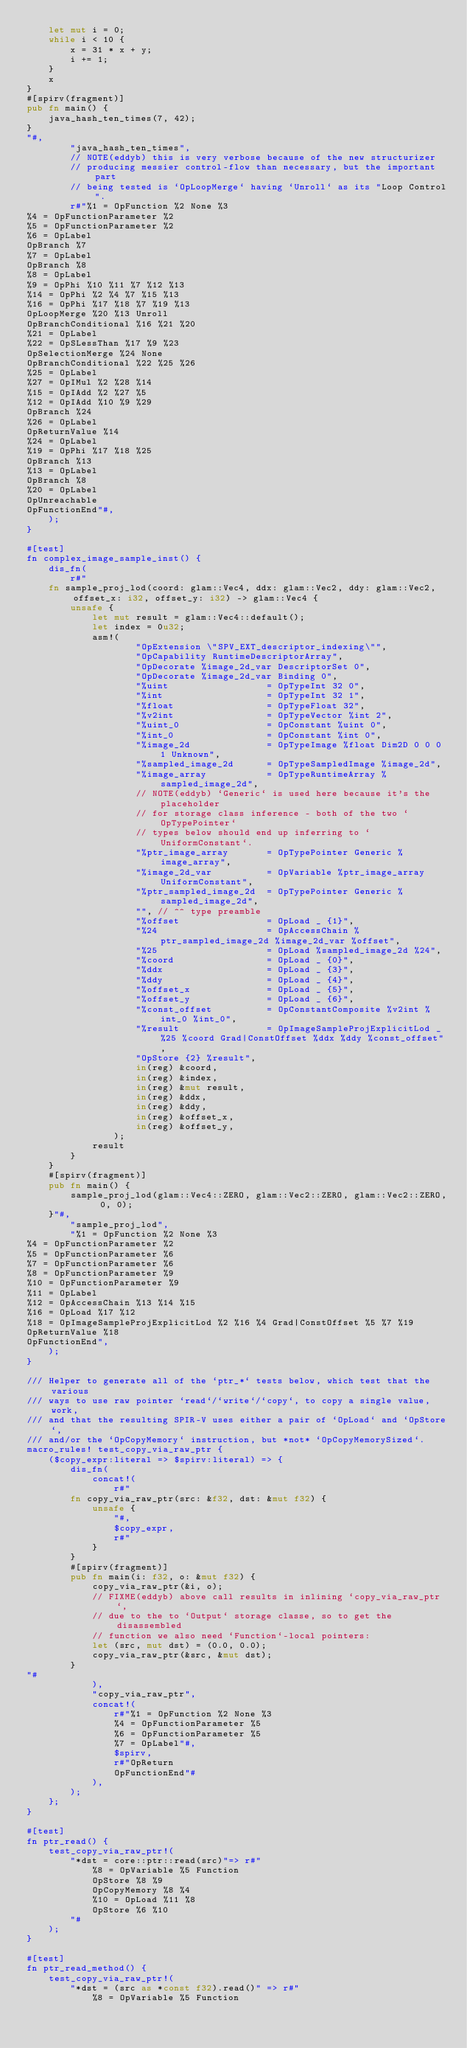Convert code to text. <code><loc_0><loc_0><loc_500><loc_500><_Rust_>    let mut i = 0;
    while i < 10 {
        x = 31 * x + y;
        i += 1;
    }
    x
}
#[spirv(fragment)]
pub fn main() {
    java_hash_ten_times(7, 42);
}
"#,
        "java_hash_ten_times",
        // NOTE(eddyb) this is very verbose because of the new structurizer
        // producing messier control-flow than necessary, but the important part
        // being tested is `OpLoopMerge` having `Unroll` as its "Loop Control".
        r#"%1 = OpFunction %2 None %3
%4 = OpFunctionParameter %2
%5 = OpFunctionParameter %2
%6 = OpLabel
OpBranch %7
%7 = OpLabel
OpBranch %8
%8 = OpLabel
%9 = OpPhi %10 %11 %7 %12 %13
%14 = OpPhi %2 %4 %7 %15 %13
%16 = OpPhi %17 %18 %7 %19 %13
OpLoopMerge %20 %13 Unroll
OpBranchConditional %16 %21 %20
%21 = OpLabel
%22 = OpSLessThan %17 %9 %23
OpSelectionMerge %24 None
OpBranchConditional %22 %25 %26
%25 = OpLabel
%27 = OpIMul %2 %28 %14
%15 = OpIAdd %2 %27 %5
%12 = OpIAdd %10 %9 %29
OpBranch %24
%26 = OpLabel
OpReturnValue %14
%24 = OpLabel
%19 = OpPhi %17 %18 %25
OpBranch %13
%13 = OpLabel
OpBranch %8
%20 = OpLabel
OpUnreachable
OpFunctionEnd"#,
    );
}

#[test]
fn complex_image_sample_inst() {
    dis_fn(
        r#"
    fn sample_proj_lod(coord: glam::Vec4, ddx: glam::Vec2, ddy: glam::Vec2, offset_x: i32, offset_y: i32) -> glam::Vec4 {
        unsafe {
            let mut result = glam::Vec4::default();
            let index = 0u32;
            asm!(
                    "OpExtension \"SPV_EXT_descriptor_indexing\"",
                    "OpCapability RuntimeDescriptorArray",
                    "OpDecorate %image_2d_var DescriptorSet 0",
                    "OpDecorate %image_2d_var Binding 0",
                    "%uint                  = OpTypeInt 32 0",
                    "%int                   = OpTypeInt 32 1",
                    "%float                 = OpTypeFloat 32",
                    "%v2int                 = OpTypeVector %int 2",
                    "%uint_0                = OpConstant %uint 0",
                    "%int_0                 = OpConstant %int 0",
                    "%image_2d              = OpTypeImage %float Dim2D 0 0 0 1 Unknown",
                    "%sampled_image_2d      = OpTypeSampledImage %image_2d",
                    "%image_array           = OpTypeRuntimeArray %sampled_image_2d",
                    // NOTE(eddyb) `Generic` is used here because it's the placeholder
                    // for storage class inference - both of the two `OpTypePointer`
                    // types below should end up inferring to `UniformConstant`.
                    "%ptr_image_array       = OpTypePointer Generic %image_array",
                    "%image_2d_var          = OpVariable %ptr_image_array UniformConstant",
                    "%ptr_sampled_image_2d  = OpTypePointer Generic %sampled_image_2d",
                    "", // ^^ type preamble
                    "%offset                = OpLoad _ {1}",
                    "%24                    = OpAccessChain %ptr_sampled_image_2d %image_2d_var %offset",
                    "%25                    = OpLoad %sampled_image_2d %24",
                    "%coord                 = OpLoad _ {0}",
                    "%ddx                   = OpLoad _ {3}",
                    "%ddy                   = OpLoad _ {4}",
                    "%offset_x              = OpLoad _ {5}",
                    "%offset_y              = OpLoad _ {6}",
                    "%const_offset          = OpConstantComposite %v2int %int_0 %int_0",
                    "%result                = OpImageSampleProjExplicitLod _ %25 %coord Grad|ConstOffset %ddx %ddy %const_offset",
                    "OpStore {2} %result",
                    in(reg) &coord,
                    in(reg) &index,
                    in(reg) &mut result,
                    in(reg) &ddx,
                    in(reg) &ddy,
                    in(reg) &offset_x,
                    in(reg) &offset_y,
                );
            result
        }
    }
    #[spirv(fragment)]
    pub fn main() {
        sample_proj_lod(glam::Vec4::ZERO, glam::Vec2::ZERO, glam::Vec2::ZERO, 0, 0);
    }"#,
        "sample_proj_lod",
        "%1 = OpFunction %2 None %3
%4 = OpFunctionParameter %2
%5 = OpFunctionParameter %6
%7 = OpFunctionParameter %6
%8 = OpFunctionParameter %9
%10 = OpFunctionParameter %9
%11 = OpLabel
%12 = OpAccessChain %13 %14 %15
%16 = OpLoad %17 %12
%18 = OpImageSampleProjExplicitLod %2 %16 %4 Grad|ConstOffset %5 %7 %19
OpReturnValue %18
OpFunctionEnd",
    );
}

/// Helper to generate all of the `ptr_*` tests below, which test that the various
/// ways to use raw pointer `read`/`write`/`copy`, to copy a single value, work,
/// and that the resulting SPIR-V uses either a pair of `OpLoad` and `OpStore`,
/// and/or the `OpCopyMemory` instruction, but *not* `OpCopyMemorySized`.
macro_rules! test_copy_via_raw_ptr {
    ($copy_expr:literal => $spirv:literal) => {
        dis_fn(
            concat!(
                r#"
        fn copy_via_raw_ptr(src: &f32, dst: &mut f32) {
            unsafe {
                "#,
                $copy_expr,
                r#"
            }
        }
        #[spirv(fragment)]
        pub fn main(i: f32, o: &mut f32) {
            copy_via_raw_ptr(&i, o);
            // FIXME(eddyb) above call results in inlining `copy_via_raw_ptr`,
            // due to the to `Output` storage classe, so to get the disassembled
            // function we also need `Function`-local pointers:
            let (src, mut dst) = (0.0, 0.0);
            copy_via_raw_ptr(&src, &mut dst);
        }
"#
            ),
            "copy_via_raw_ptr",
            concat!(
                r#"%1 = OpFunction %2 None %3
                %4 = OpFunctionParameter %5
                %6 = OpFunctionParameter %5
                %7 = OpLabel"#,
                $spirv,
                r#"OpReturn
                OpFunctionEnd"#
            ),
        );
    };
}

#[test]
fn ptr_read() {
    test_copy_via_raw_ptr!(
        "*dst = core::ptr::read(src)"=> r#"
            %8 = OpVariable %5 Function
            OpStore %8 %9
            OpCopyMemory %8 %4
            %10 = OpLoad %11 %8
            OpStore %6 %10
        "#
    );
}

#[test]
fn ptr_read_method() {
    test_copy_via_raw_ptr!(
        "*dst = (src as *const f32).read()" => r#"
            %8 = OpVariable %5 Function</code> 